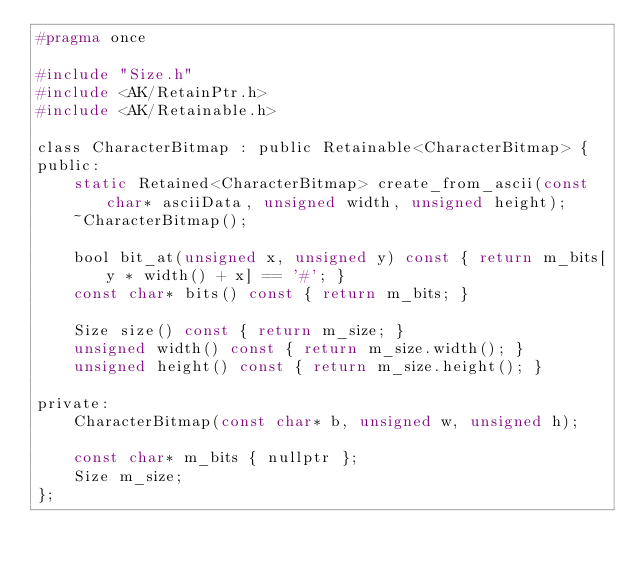Convert code to text. <code><loc_0><loc_0><loc_500><loc_500><_C_>#pragma once

#include "Size.h"
#include <AK/RetainPtr.h>
#include <AK/Retainable.h>

class CharacterBitmap : public Retainable<CharacterBitmap> {
public:
    static Retained<CharacterBitmap> create_from_ascii(const char* asciiData, unsigned width, unsigned height);
    ~CharacterBitmap();

    bool bit_at(unsigned x, unsigned y) const { return m_bits[y * width() + x] == '#'; }
    const char* bits() const { return m_bits; }

    Size size() const { return m_size; }
    unsigned width() const { return m_size.width(); }
    unsigned height() const { return m_size.height(); }

private:
    CharacterBitmap(const char* b, unsigned w, unsigned h);

    const char* m_bits { nullptr };
    Size m_size;
};
</code> 